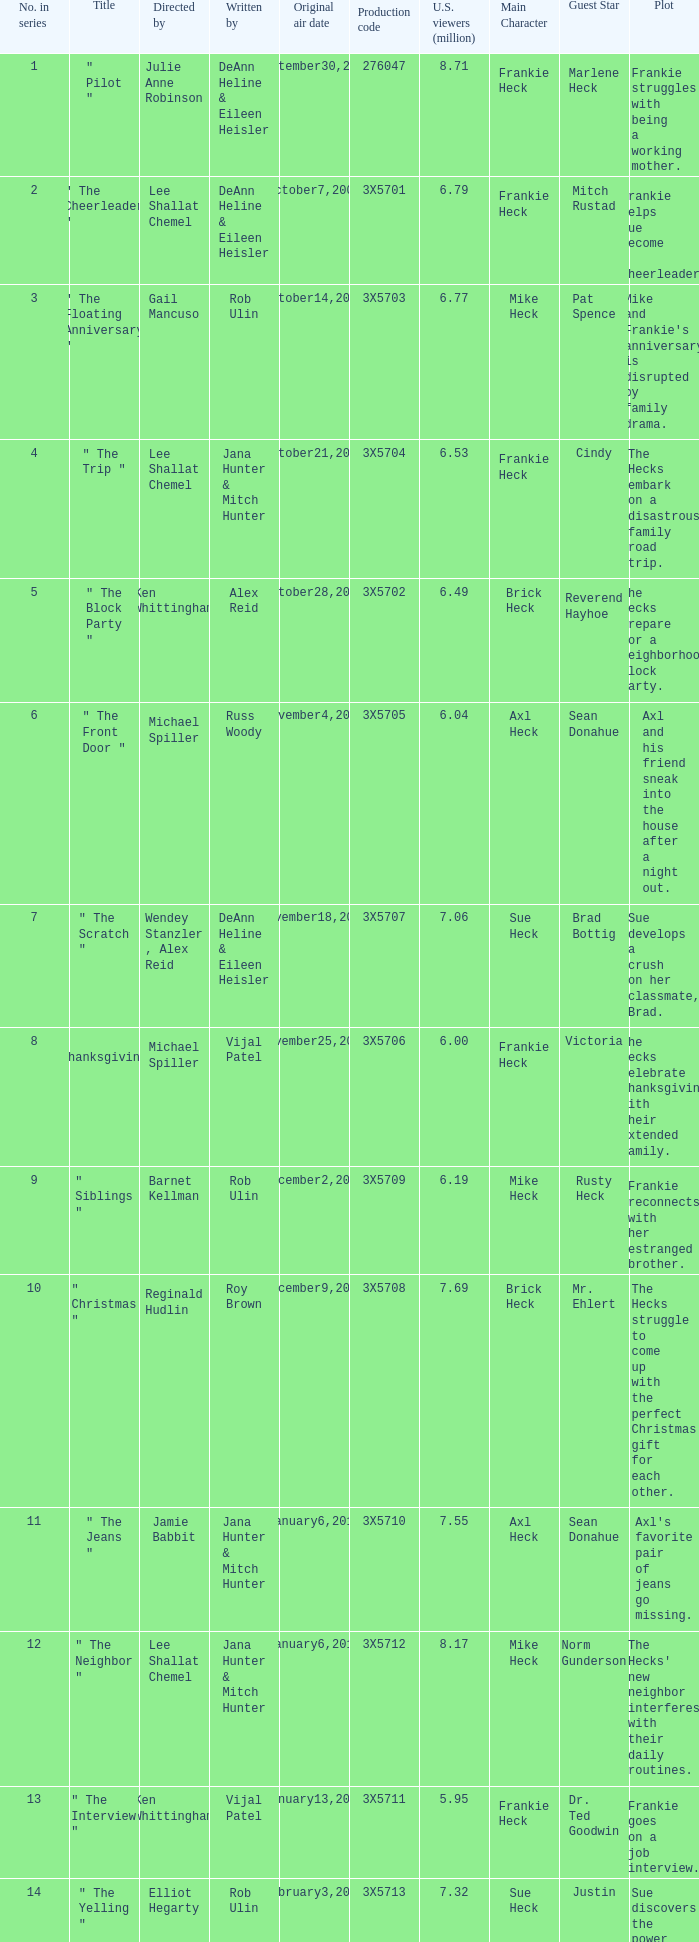What is the title of the episode Alex Reid directed? "The Final Four". 